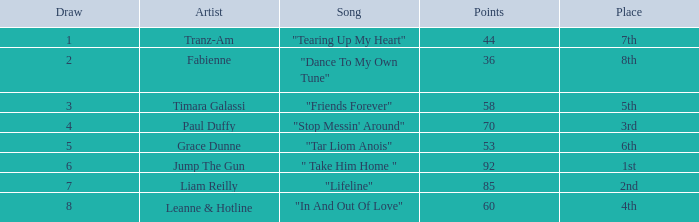How many points does grace dunne have when a draw is more than 5? 0.0. Could you parse the entire table? {'header': ['Draw', 'Artist', 'Song', 'Points', 'Place'], 'rows': [['1', 'Tranz-Am', '"Tearing Up My Heart"', '44', '7th'], ['2', 'Fabienne', '"Dance To My Own Tune"', '36', '8th'], ['3', 'Timara Galassi', '"Friends Forever"', '58', '5th'], ['4', 'Paul Duffy', '"Stop Messin\' Around"', '70', '3rd'], ['5', 'Grace Dunne', '"Tar Liom Anois"', '53', '6th'], ['6', 'Jump The Gun', '" Take Him Home "', '92', '1st'], ['7', 'Liam Reilly', '"Lifeline"', '85', '2nd'], ['8', 'Leanne & Hotline', '"In And Out Of Love"', '60', '4th']]} 